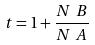<formula> <loc_0><loc_0><loc_500><loc_500>t = 1 + \frac { N _ { \ } B } { N _ { \ } A }</formula> 